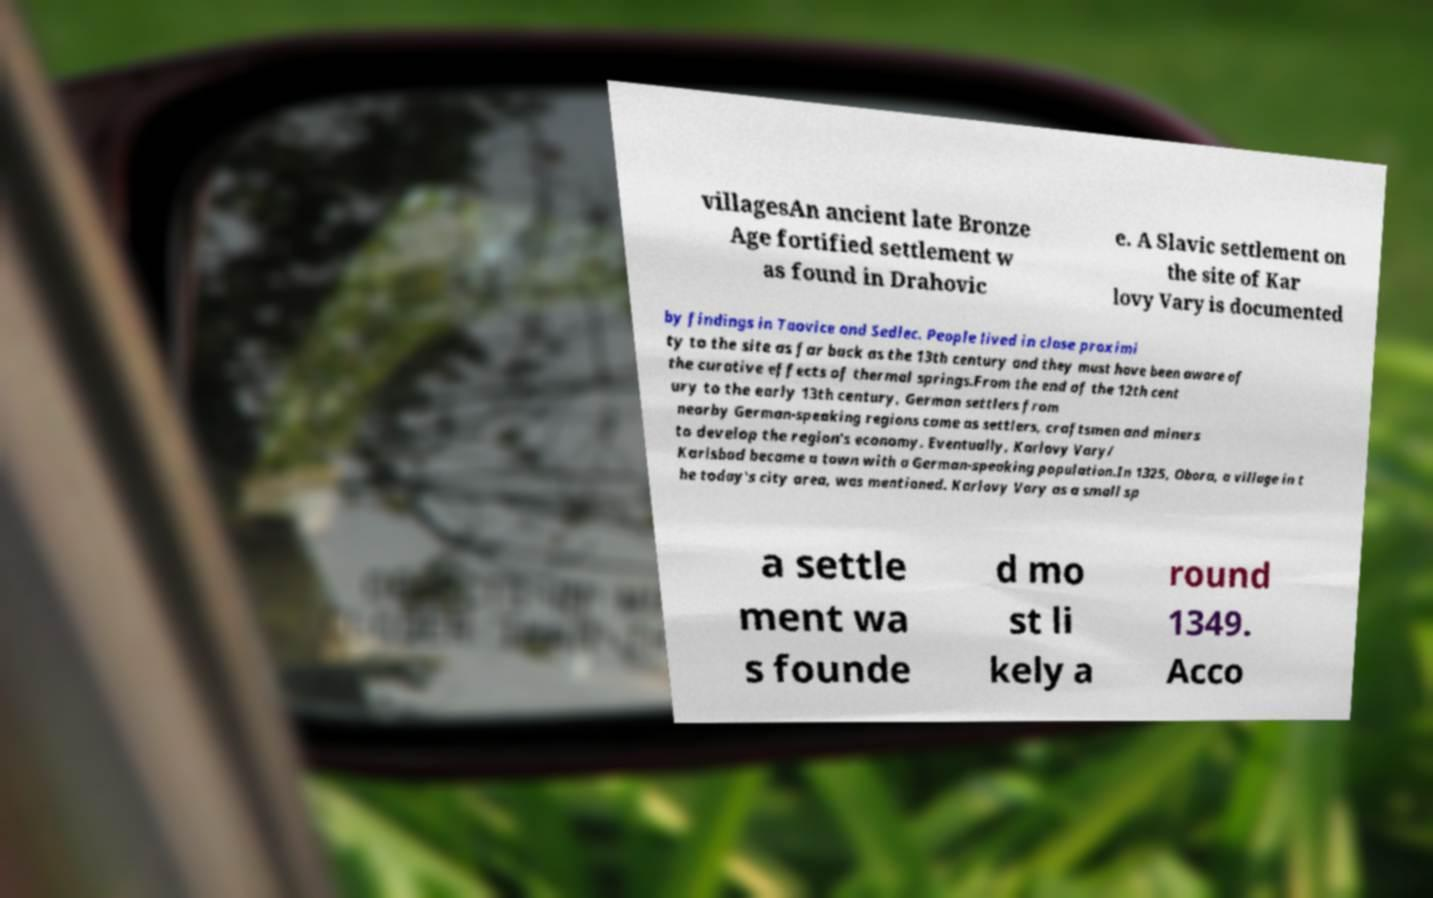Could you extract and type out the text from this image? villagesAn ancient late Bronze Age fortified settlement w as found in Drahovic e. A Slavic settlement on the site of Kar lovy Vary is documented by findings in Taovice and Sedlec. People lived in close proximi ty to the site as far back as the 13th century and they must have been aware of the curative effects of thermal springs.From the end of the 12th cent ury to the early 13th century, German settlers from nearby German-speaking regions came as settlers, craftsmen and miners to develop the region's economy. Eventually, Karlovy Vary/ Karlsbad became a town with a German-speaking population.In 1325, Obora, a village in t he today's city area, was mentioned. Karlovy Vary as a small sp a settle ment wa s founde d mo st li kely a round 1349. Acco 